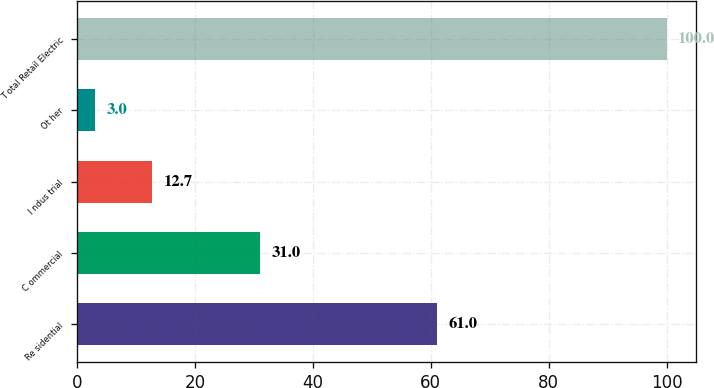Convert chart. <chart><loc_0><loc_0><loc_500><loc_500><bar_chart><fcel>Re sidential<fcel>C ommercial<fcel>I ndus trial<fcel>Ot her<fcel>T otal Retail Electric<nl><fcel>61<fcel>31<fcel>12.7<fcel>3<fcel>100<nl></chart> 